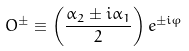Convert formula to latex. <formula><loc_0><loc_0><loc_500><loc_500>O ^ { \pm } \equiv \left ( \frac { \alpha _ { 2 } \pm i \alpha _ { 1 } } { 2 } \right ) e ^ { \pm i \varphi }</formula> 